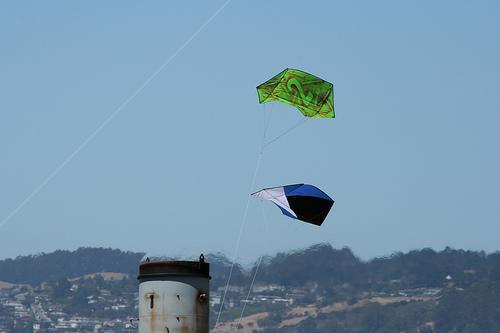How many kites are in the sky?
Give a very brief answer. 2. 